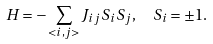Convert formula to latex. <formula><loc_0><loc_0><loc_500><loc_500>H = - \sum _ { < i , j > } J _ { i j } S _ { i } S _ { j } , \ \ S _ { i } = \pm 1 .</formula> 